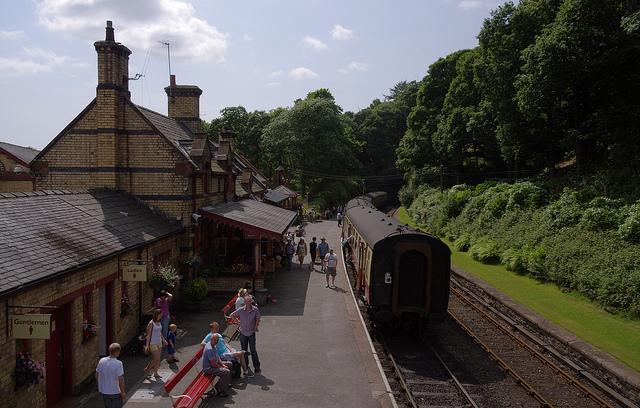In what direction will the train go next with respect to the person taking this person? Please explain your reasoning. north. Camera is behind train so train is pointed north of the person taking the photo 